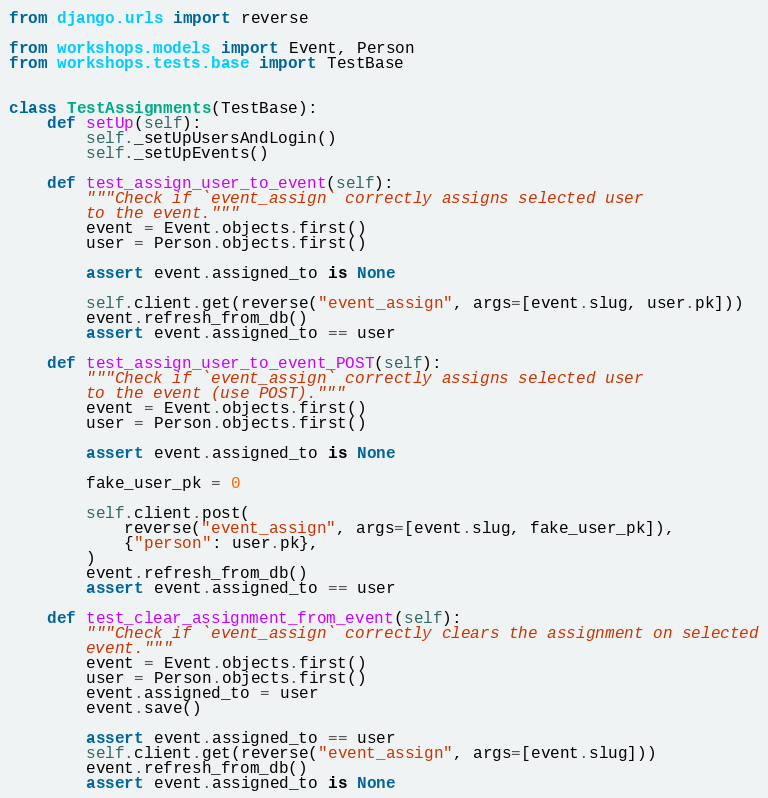Convert code to text. <code><loc_0><loc_0><loc_500><loc_500><_Python_>from django.urls import reverse

from workshops.models import Event, Person
from workshops.tests.base import TestBase


class TestAssignments(TestBase):
    def setUp(self):
        self._setUpUsersAndLogin()
        self._setUpEvents()

    def test_assign_user_to_event(self):
        """Check if `event_assign` correctly assigns selected user
        to the event."""
        event = Event.objects.first()
        user = Person.objects.first()

        assert event.assigned_to is None

        self.client.get(reverse("event_assign", args=[event.slug, user.pk]))
        event.refresh_from_db()
        assert event.assigned_to == user

    def test_assign_user_to_event_POST(self):
        """Check if `event_assign` correctly assigns selected user
        to the event (use POST)."""
        event = Event.objects.first()
        user = Person.objects.first()

        assert event.assigned_to is None

        fake_user_pk = 0

        self.client.post(
            reverse("event_assign", args=[event.slug, fake_user_pk]),
            {"person": user.pk},
        )
        event.refresh_from_db()
        assert event.assigned_to == user

    def test_clear_assignment_from_event(self):
        """Check if `event_assign` correctly clears the assignment on selected
        event."""
        event = Event.objects.first()
        user = Person.objects.first()
        event.assigned_to = user
        event.save()

        assert event.assigned_to == user
        self.client.get(reverse("event_assign", args=[event.slug]))
        event.refresh_from_db()
        assert event.assigned_to is None
</code> 